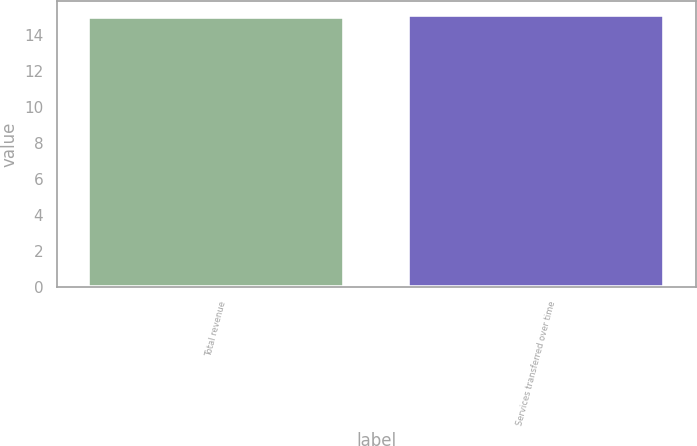Convert chart to OTSL. <chart><loc_0><loc_0><loc_500><loc_500><bar_chart><fcel>Total revenue<fcel>Services transferred over time<nl><fcel>15<fcel>15.1<nl></chart> 